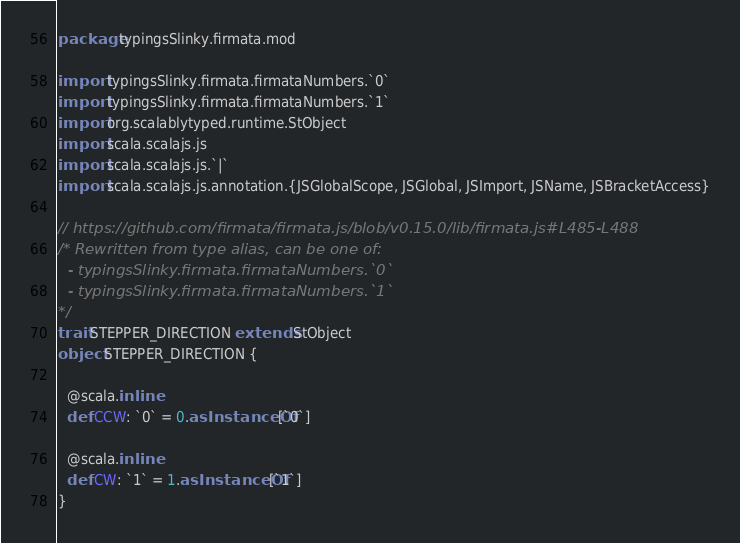Convert code to text. <code><loc_0><loc_0><loc_500><loc_500><_Scala_>package typingsSlinky.firmata.mod

import typingsSlinky.firmata.firmataNumbers.`0`
import typingsSlinky.firmata.firmataNumbers.`1`
import org.scalablytyped.runtime.StObject
import scala.scalajs.js
import scala.scalajs.js.`|`
import scala.scalajs.js.annotation.{JSGlobalScope, JSGlobal, JSImport, JSName, JSBracketAccess}

// https://github.com/firmata/firmata.js/blob/v0.15.0/lib/firmata.js#L485-L488
/* Rewritten from type alias, can be one of: 
  - typingsSlinky.firmata.firmataNumbers.`0`
  - typingsSlinky.firmata.firmataNumbers.`1`
*/
trait STEPPER_DIRECTION extends StObject
object STEPPER_DIRECTION {
  
  @scala.inline
  def CCW: `0` = 0.asInstanceOf[`0`]
  
  @scala.inline
  def CW: `1` = 1.asInstanceOf[`1`]
}
</code> 